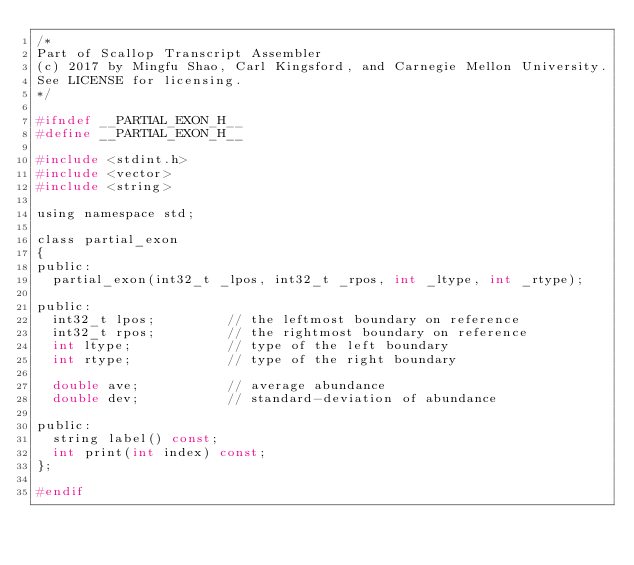<code> <loc_0><loc_0><loc_500><loc_500><_C_>/*
Part of Scallop Transcript Assembler
(c) 2017 by Mingfu Shao, Carl Kingsford, and Carnegie Mellon University.
See LICENSE for licensing.
*/

#ifndef __PARTIAL_EXON_H__
#define __PARTIAL_EXON_H__

#include <stdint.h>
#include <vector>
#include <string>

using namespace std;

class partial_exon
{
public:
	partial_exon(int32_t _lpos, int32_t _rpos, int _ltype, int _rtype);

public:
	int32_t lpos;					// the leftmost boundary on reference
	int32_t rpos;					// the rightmost boundary on reference
	int ltype;						// type of the left boundary
	int rtype;						// type of the right boundary

	double ave;						// average abundance
	double dev;						// standard-deviation of abundance

public:
	string label() const;
	int print(int index) const;
};

#endif
</code> 